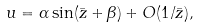<formula> <loc_0><loc_0><loc_500><loc_500>u = \alpha \sin ( \bar { z } + \beta ) + O ( 1 / \bar { z } ) ,</formula> 